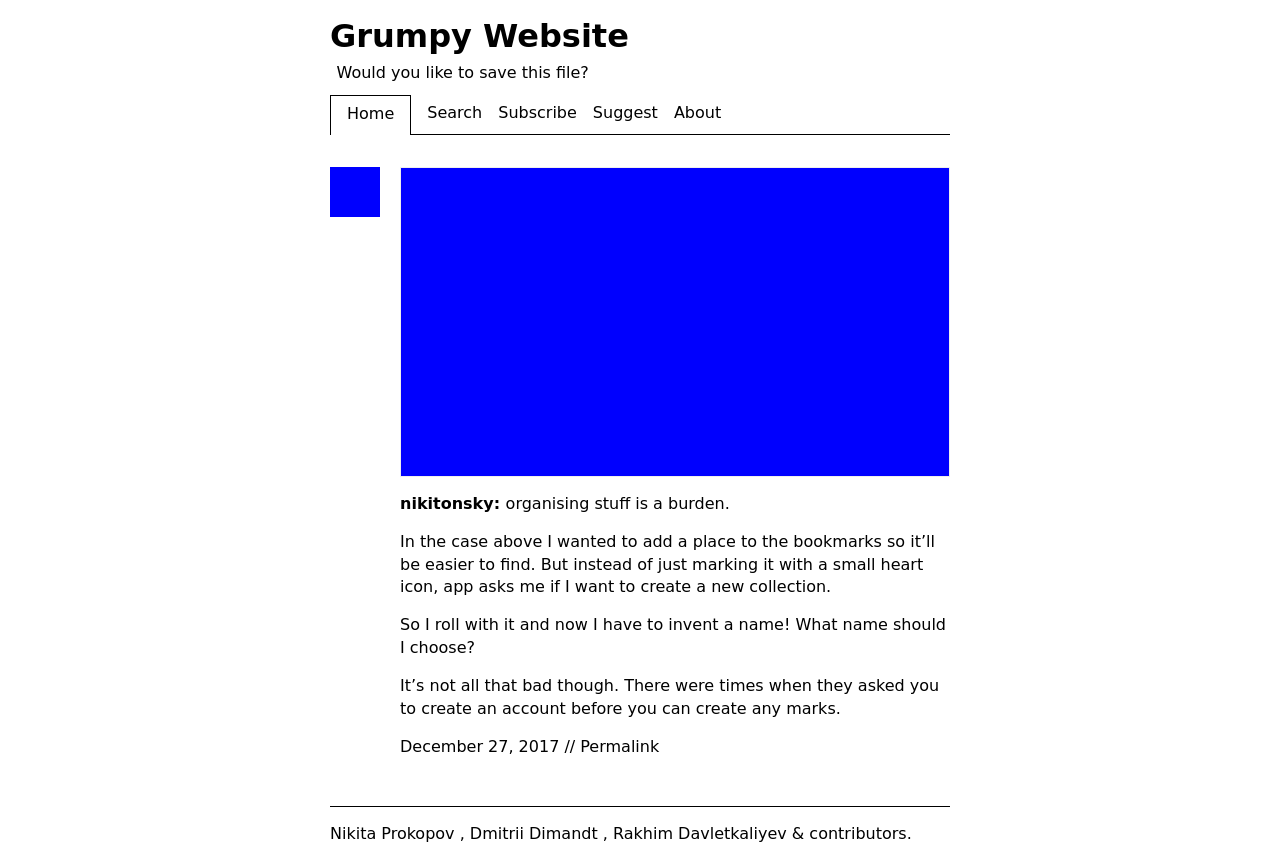What are the main themes discussed on this website? Based on the displayed content, the main themes of the website revolve around web design and user experience frustrations, particularly focusing on the unnecessary complexities of managing digital content and user interface design.  Can you tell more about the design choices shown in the image? The design emphasizes simplicity and readability. It uses a minimalist color scheme predominantly featuring blues and whites, which keeps the focus on the textual content. The navigation menu is straightforward, and there's a clear distinction between different sections using borders and spacing. 